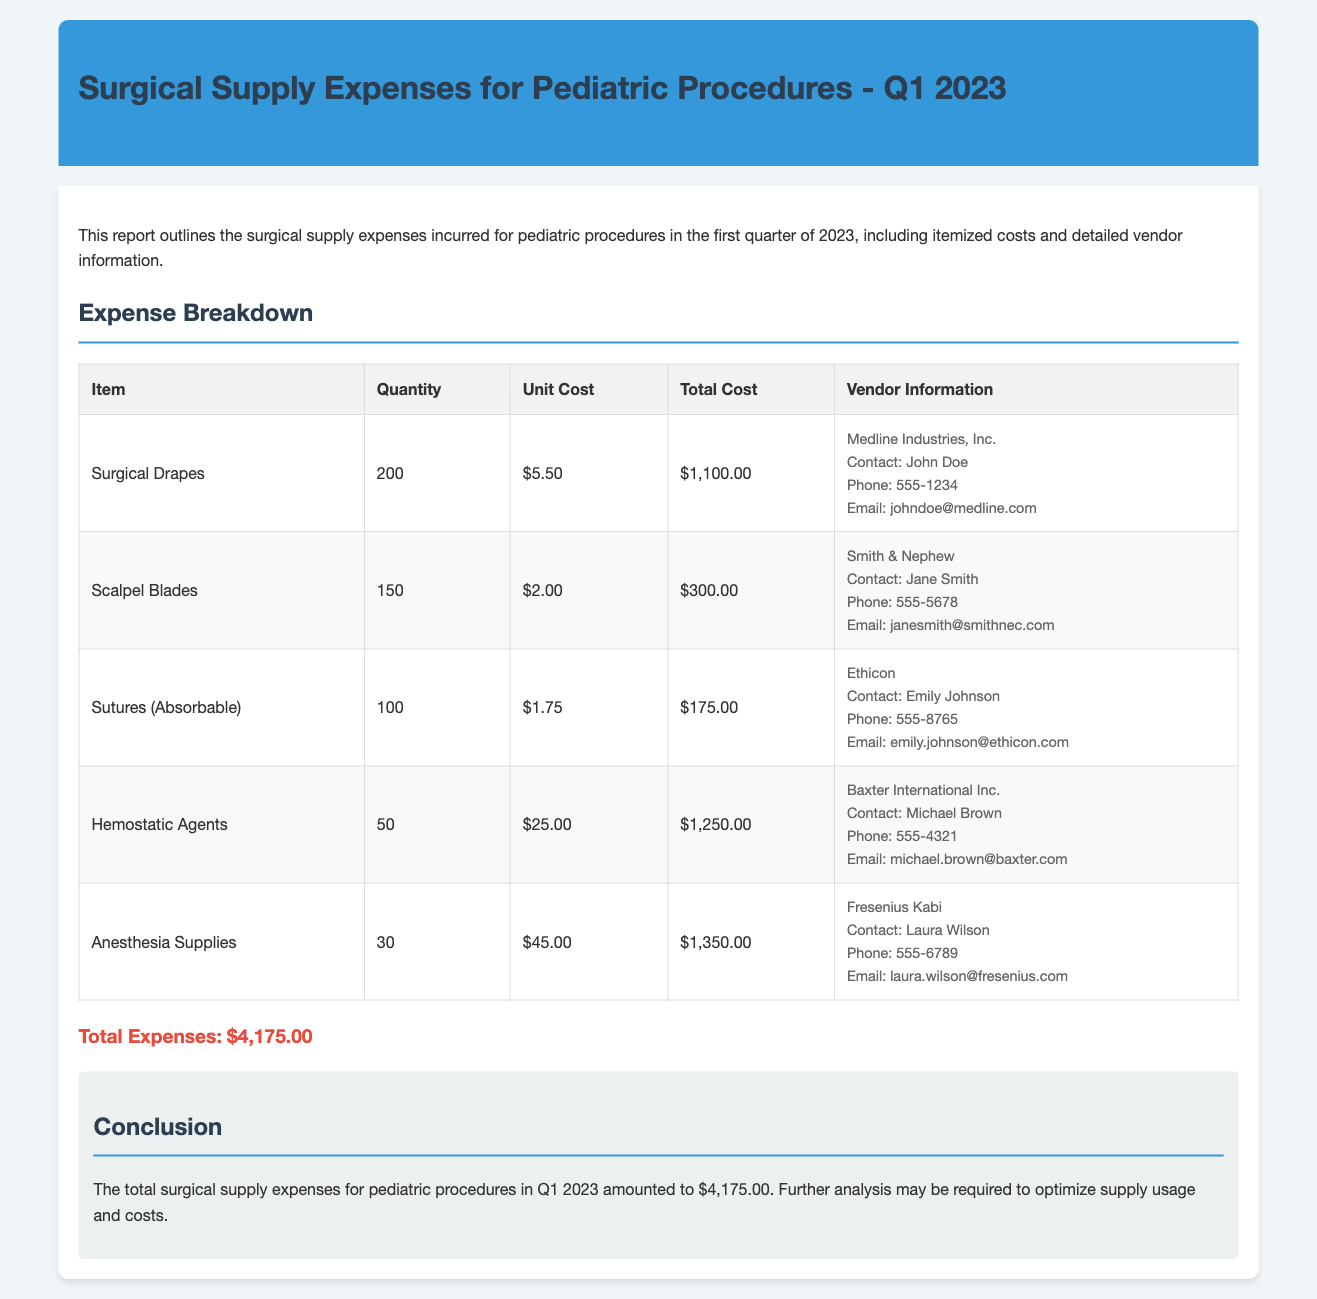What is the total expense for surgical supplies? The total expense is clearly stated at the bottom of the report as the sum of all itemized costs.
Answer: $4,175.00 How many surgical drapes were purchased? The report specifies the quantity of surgical drapes in the expense breakdown table.
Answer: 200 What is the unit cost of hemostatic agents? The unit cost is mentioned in the expense breakdown for hemostatic agents.
Answer: $25.00 Who is the contact person for anesthesia supplies? The vendor information includes a contact for anesthesia supplies.
Answer: Laura Wilson Which vendor supplies the absorbable sutures? The expense breakdown indicates which vendor provides absorbable sutures.
Answer: Ethicon What is the total cost of scalpel blades? The total cost for scalpel blades can be obtained from the expense breakdown.
Answer: $300.00 Which item had the highest total cost? The highest total cost can be determined by assessing the total costs of each item in the report.
Answer: Hemostatic Agents What is the contact email for Medline Industries, Inc.? The vendor information outlines the contact email for Medline Industries, Inc.
Answer: johndoe@medline.com How many anesthesia supplies were ordered? The quantity ordered is specified in the expense breakdown for anesthesia supplies.
Answer: 30 